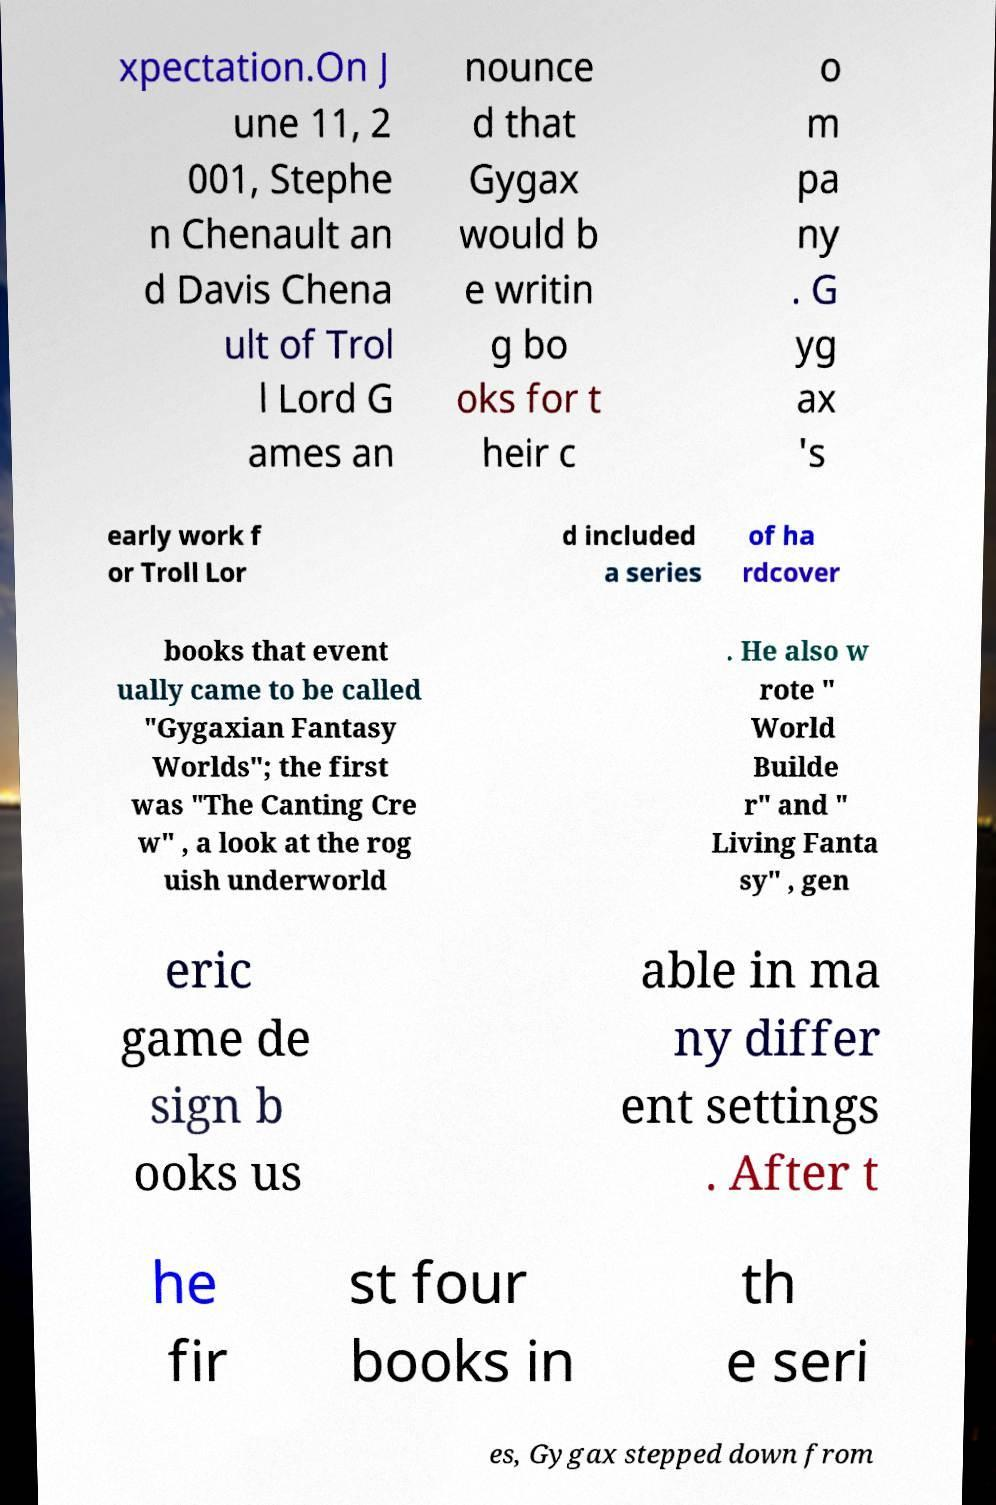Could you assist in decoding the text presented in this image and type it out clearly? xpectation.On J une 11, 2 001, Stephe n Chenault an d Davis Chena ult of Trol l Lord G ames an nounce d that Gygax would b e writin g bo oks for t heir c o m pa ny . G yg ax 's early work f or Troll Lor d included a series of ha rdcover books that event ually came to be called "Gygaxian Fantasy Worlds"; the first was "The Canting Cre w" , a look at the rog uish underworld . He also w rote " World Builde r" and " Living Fanta sy" , gen eric game de sign b ooks us able in ma ny differ ent settings . After t he fir st four books in th e seri es, Gygax stepped down from 